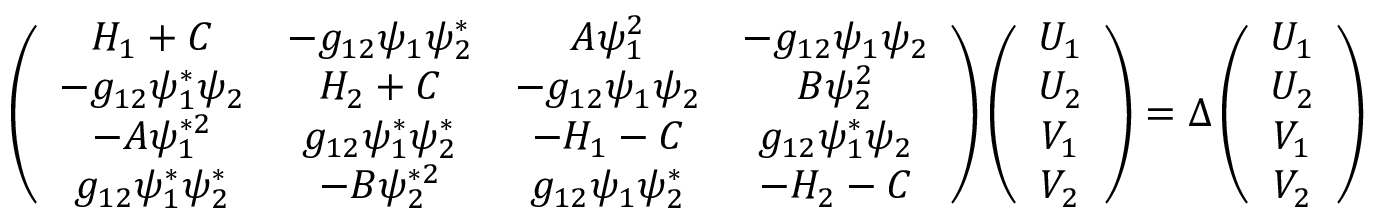Convert formula to latex. <formula><loc_0><loc_0><loc_500><loc_500>\begin{array} { r } { \left ( \begin{array} { c c c c } { H _ { 1 } + C } & { - g _ { 1 2 } \psi _ { 1 } \psi _ { 2 } ^ { * } } & { A \psi _ { 1 } ^ { 2 } } & { - g _ { 1 2 } \psi _ { 1 } \psi _ { 2 } } \\ { - g _ { 1 2 } \psi _ { 1 } ^ { * } \psi _ { 2 } } & { H _ { 2 } + C } & { - g _ { 1 2 } \psi _ { 1 } \psi _ { 2 } } & { B \psi _ { 2 } ^ { 2 } } \\ { - A \psi _ { 1 } ^ { * 2 } } & { g _ { 1 2 } \psi _ { 1 } ^ { * } \psi _ { 2 } ^ { * } } & { - H _ { 1 } - C } & { g _ { 1 2 } \psi _ { 1 } ^ { * } \psi _ { 2 } } \\ { g _ { 1 2 } \psi _ { 1 } ^ { * } \psi _ { 2 } ^ { * } } & { - B \psi _ { 2 } ^ { * 2 } } & { g _ { 1 2 } \psi _ { 1 } \psi _ { 2 } ^ { * } } & { - H _ { 2 } - C } \end{array} \right ) \left ( \begin{array} { c } { U _ { 1 } } \\ { U _ { 2 } } \\ { V _ { 1 } } \\ { V _ { 2 } } \end{array} \right ) = \Delta \left ( \begin{array} { c } { U _ { 1 } } \\ { U _ { 2 } } \\ { V _ { 1 } } \\ { V _ { 2 } } \end{array} \right ) } \end{array}</formula> 